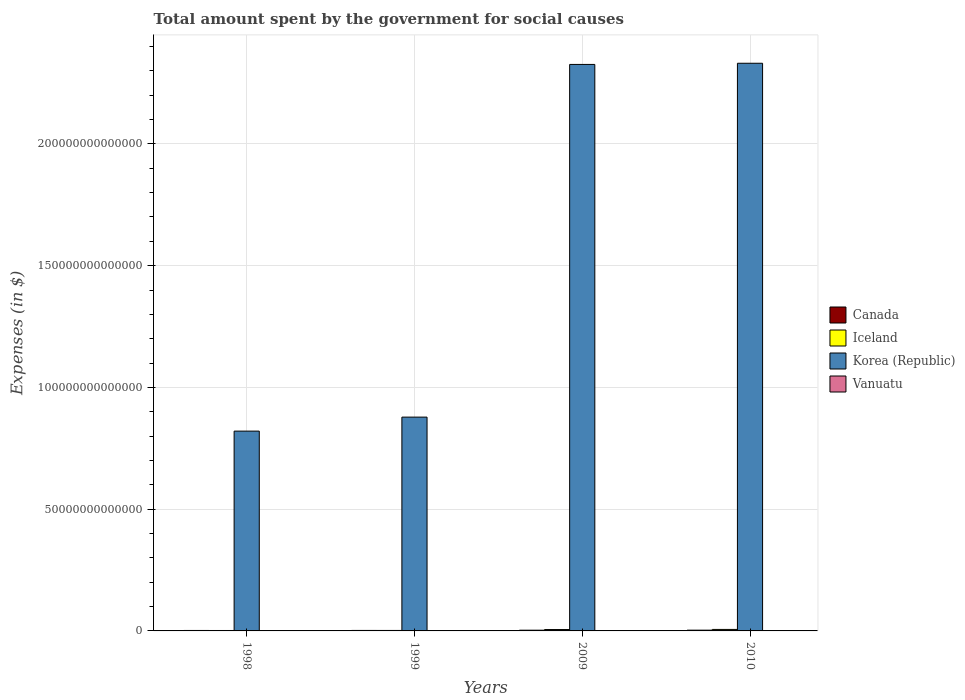How many different coloured bars are there?
Your response must be concise. 4. How many groups of bars are there?
Offer a very short reply. 4. Are the number of bars on each tick of the X-axis equal?
Offer a very short reply. Yes. What is the amount spent for social causes by the government in Vanuatu in 1998?
Give a very brief answer. 6.40e+09. Across all years, what is the maximum amount spent for social causes by the government in Canada?
Provide a succinct answer. 3.13e+11. Across all years, what is the minimum amount spent for social causes by the government in Canada?
Keep it short and to the point. 1.89e+11. What is the total amount spent for social causes by the government in Iceland in the graph?
Your response must be concise. 1.55e+12. What is the difference between the amount spent for social causes by the government in Canada in 1998 and that in 2009?
Offer a very short reply. -1.07e+11. What is the difference between the amount spent for social causes by the government in Korea (Republic) in 1998 and the amount spent for social causes by the government in Canada in 1999?
Ensure brevity in your answer.  8.19e+13. What is the average amount spent for social causes by the government in Iceland per year?
Make the answer very short. 3.88e+11. In the year 1998, what is the difference between the amount spent for social causes by the government in Canada and amount spent for social causes by the government in Vanuatu?
Provide a short and direct response. 1.83e+11. In how many years, is the amount spent for social causes by the government in Canada greater than 50000000000000 $?
Your answer should be very brief. 0. What is the ratio of the amount spent for social causes by the government in Vanuatu in 2009 to that in 2010?
Ensure brevity in your answer.  0.88. What is the difference between the highest and the second highest amount spent for social causes by the government in Korea (Republic)?
Your answer should be very brief. 4.79e+11. What is the difference between the highest and the lowest amount spent for social causes by the government in Canada?
Make the answer very short. 1.24e+11. In how many years, is the amount spent for social causes by the government in Korea (Republic) greater than the average amount spent for social causes by the government in Korea (Republic) taken over all years?
Your response must be concise. 2. Is it the case that in every year, the sum of the amount spent for social causes by the government in Vanuatu and amount spent for social causes by the government in Canada is greater than the sum of amount spent for social causes by the government in Iceland and amount spent for social causes by the government in Korea (Republic)?
Provide a succinct answer. Yes. What does the 1st bar from the left in 1999 represents?
Your answer should be very brief. Canada. What is the difference between two consecutive major ticks on the Y-axis?
Give a very brief answer. 5.00e+13. Are the values on the major ticks of Y-axis written in scientific E-notation?
Provide a succinct answer. No. Where does the legend appear in the graph?
Offer a very short reply. Center right. How are the legend labels stacked?
Your answer should be compact. Vertical. What is the title of the graph?
Give a very brief answer. Total amount spent by the government for social causes. What is the label or title of the Y-axis?
Ensure brevity in your answer.  Expenses (in $). What is the Expenses (in $) of Canada in 1998?
Your response must be concise. 1.89e+11. What is the Expenses (in $) of Iceland in 1998?
Your answer should be compact. 1.77e+11. What is the Expenses (in $) in Korea (Republic) in 1998?
Your response must be concise. 8.21e+13. What is the Expenses (in $) of Vanuatu in 1998?
Offer a very short reply. 6.40e+09. What is the Expenses (in $) in Canada in 1999?
Offer a terse response. 1.99e+11. What is the Expenses (in $) in Iceland in 1999?
Make the answer very short. 1.94e+11. What is the Expenses (in $) of Korea (Republic) in 1999?
Ensure brevity in your answer.  8.78e+13. What is the Expenses (in $) of Vanuatu in 1999?
Give a very brief answer. 6.51e+09. What is the Expenses (in $) in Canada in 2009?
Your response must be concise. 2.96e+11. What is the Expenses (in $) in Iceland in 2009?
Provide a short and direct response. 5.71e+11. What is the Expenses (in $) of Korea (Republic) in 2009?
Provide a succinct answer. 2.33e+14. What is the Expenses (in $) in Vanuatu in 2009?
Keep it short and to the point. 1.33e+1. What is the Expenses (in $) of Canada in 2010?
Your response must be concise. 3.13e+11. What is the Expenses (in $) in Iceland in 2010?
Your answer should be very brief. 6.10e+11. What is the Expenses (in $) of Korea (Republic) in 2010?
Make the answer very short. 2.33e+14. What is the Expenses (in $) of Vanuatu in 2010?
Your answer should be very brief. 1.51e+1. Across all years, what is the maximum Expenses (in $) in Canada?
Provide a succinct answer. 3.13e+11. Across all years, what is the maximum Expenses (in $) in Iceland?
Give a very brief answer. 6.10e+11. Across all years, what is the maximum Expenses (in $) in Korea (Republic)?
Your answer should be compact. 2.33e+14. Across all years, what is the maximum Expenses (in $) of Vanuatu?
Offer a very short reply. 1.51e+1. Across all years, what is the minimum Expenses (in $) in Canada?
Ensure brevity in your answer.  1.89e+11. Across all years, what is the minimum Expenses (in $) of Iceland?
Give a very brief answer. 1.77e+11. Across all years, what is the minimum Expenses (in $) in Korea (Republic)?
Your response must be concise. 8.21e+13. Across all years, what is the minimum Expenses (in $) of Vanuatu?
Your answer should be very brief. 6.40e+09. What is the total Expenses (in $) in Canada in the graph?
Your answer should be compact. 9.98e+11. What is the total Expenses (in $) in Iceland in the graph?
Your answer should be very brief. 1.55e+12. What is the total Expenses (in $) of Korea (Republic) in the graph?
Offer a terse response. 6.36e+14. What is the total Expenses (in $) of Vanuatu in the graph?
Offer a very short reply. 4.13e+1. What is the difference between the Expenses (in $) in Canada in 1998 and that in 1999?
Your answer should be very brief. -9.53e+09. What is the difference between the Expenses (in $) of Iceland in 1998 and that in 1999?
Your response must be concise. -1.73e+1. What is the difference between the Expenses (in $) of Korea (Republic) in 1998 and that in 1999?
Provide a succinct answer. -5.75e+12. What is the difference between the Expenses (in $) in Vanuatu in 1998 and that in 1999?
Provide a succinct answer. -1.08e+08. What is the difference between the Expenses (in $) of Canada in 1998 and that in 2009?
Offer a very short reply. -1.07e+11. What is the difference between the Expenses (in $) in Iceland in 1998 and that in 2009?
Give a very brief answer. -3.94e+11. What is the difference between the Expenses (in $) of Korea (Republic) in 1998 and that in 2009?
Provide a short and direct response. -1.51e+14. What is the difference between the Expenses (in $) of Vanuatu in 1998 and that in 2009?
Ensure brevity in your answer.  -6.87e+09. What is the difference between the Expenses (in $) of Canada in 1998 and that in 2010?
Your answer should be compact. -1.24e+11. What is the difference between the Expenses (in $) in Iceland in 1998 and that in 2010?
Give a very brief answer. -4.33e+11. What is the difference between the Expenses (in $) of Korea (Republic) in 1998 and that in 2010?
Your answer should be very brief. -1.51e+14. What is the difference between the Expenses (in $) in Vanuatu in 1998 and that in 2010?
Your answer should be compact. -8.71e+09. What is the difference between the Expenses (in $) of Canada in 1999 and that in 2009?
Offer a very short reply. -9.73e+1. What is the difference between the Expenses (in $) of Iceland in 1999 and that in 2009?
Your answer should be compact. -3.77e+11. What is the difference between the Expenses (in $) of Korea (Republic) in 1999 and that in 2009?
Provide a short and direct response. -1.45e+14. What is the difference between the Expenses (in $) of Vanuatu in 1999 and that in 2009?
Ensure brevity in your answer.  -6.76e+09. What is the difference between the Expenses (in $) of Canada in 1999 and that in 2010?
Offer a very short reply. -1.14e+11. What is the difference between the Expenses (in $) of Iceland in 1999 and that in 2010?
Provide a succinct answer. -4.16e+11. What is the difference between the Expenses (in $) of Korea (Republic) in 1999 and that in 2010?
Ensure brevity in your answer.  -1.45e+14. What is the difference between the Expenses (in $) of Vanuatu in 1999 and that in 2010?
Offer a very short reply. -8.60e+09. What is the difference between the Expenses (in $) of Canada in 2009 and that in 2010?
Give a very brief answer. -1.68e+1. What is the difference between the Expenses (in $) in Iceland in 2009 and that in 2010?
Your answer should be very brief. -3.92e+1. What is the difference between the Expenses (in $) in Korea (Republic) in 2009 and that in 2010?
Make the answer very short. -4.79e+11. What is the difference between the Expenses (in $) of Vanuatu in 2009 and that in 2010?
Provide a short and direct response. -1.84e+09. What is the difference between the Expenses (in $) of Canada in 1998 and the Expenses (in $) of Iceland in 1999?
Provide a short and direct response. -4.72e+09. What is the difference between the Expenses (in $) of Canada in 1998 and the Expenses (in $) of Korea (Republic) in 1999?
Your answer should be very brief. -8.76e+13. What is the difference between the Expenses (in $) of Canada in 1998 and the Expenses (in $) of Vanuatu in 1999?
Your answer should be very brief. 1.83e+11. What is the difference between the Expenses (in $) in Iceland in 1998 and the Expenses (in $) in Korea (Republic) in 1999?
Make the answer very short. -8.76e+13. What is the difference between the Expenses (in $) of Iceland in 1998 and the Expenses (in $) of Vanuatu in 1999?
Ensure brevity in your answer.  1.70e+11. What is the difference between the Expenses (in $) of Korea (Republic) in 1998 and the Expenses (in $) of Vanuatu in 1999?
Your answer should be compact. 8.21e+13. What is the difference between the Expenses (in $) in Canada in 1998 and the Expenses (in $) in Iceland in 2009?
Offer a terse response. -3.81e+11. What is the difference between the Expenses (in $) in Canada in 1998 and the Expenses (in $) in Korea (Republic) in 2009?
Make the answer very short. -2.32e+14. What is the difference between the Expenses (in $) of Canada in 1998 and the Expenses (in $) of Vanuatu in 2009?
Provide a succinct answer. 1.76e+11. What is the difference between the Expenses (in $) in Iceland in 1998 and the Expenses (in $) in Korea (Republic) in 2009?
Your answer should be very brief. -2.32e+14. What is the difference between the Expenses (in $) of Iceland in 1998 and the Expenses (in $) of Vanuatu in 2009?
Your answer should be compact. 1.64e+11. What is the difference between the Expenses (in $) of Korea (Republic) in 1998 and the Expenses (in $) of Vanuatu in 2009?
Ensure brevity in your answer.  8.20e+13. What is the difference between the Expenses (in $) in Canada in 1998 and the Expenses (in $) in Iceland in 2010?
Offer a very short reply. -4.20e+11. What is the difference between the Expenses (in $) of Canada in 1998 and the Expenses (in $) of Korea (Republic) in 2010?
Keep it short and to the point. -2.33e+14. What is the difference between the Expenses (in $) in Canada in 1998 and the Expenses (in $) in Vanuatu in 2010?
Your answer should be compact. 1.74e+11. What is the difference between the Expenses (in $) of Iceland in 1998 and the Expenses (in $) of Korea (Republic) in 2010?
Give a very brief answer. -2.33e+14. What is the difference between the Expenses (in $) in Iceland in 1998 and the Expenses (in $) in Vanuatu in 2010?
Offer a very short reply. 1.62e+11. What is the difference between the Expenses (in $) of Korea (Republic) in 1998 and the Expenses (in $) of Vanuatu in 2010?
Offer a very short reply. 8.20e+13. What is the difference between the Expenses (in $) in Canada in 1999 and the Expenses (in $) in Iceland in 2009?
Provide a short and direct response. -3.72e+11. What is the difference between the Expenses (in $) of Canada in 1999 and the Expenses (in $) of Korea (Republic) in 2009?
Provide a short and direct response. -2.32e+14. What is the difference between the Expenses (in $) in Canada in 1999 and the Expenses (in $) in Vanuatu in 2009?
Your response must be concise. 1.86e+11. What is the difference between the Expenses (in $) in Iceland in 1999 and the Expenses (in $) in Korea (Republic) in 2009?
Give a very brief answer. -2.32e+14. What is the difference between the Expenses (in $) of Iceland in 1999 and the Expenses (in $) of Vanuatu in 2009?
Give a very brief answer. 1.81e+11. What is the difference between the Expenses (in $) in Korea (Republic) in 1999 and the Expenses (in $) in Vanuatu in 2009?
Offer a very short reply. 8.78e+13. What is the difference between the Expenses (in $) of Canada in 1999 and the Expenses (in $) of Iceland in 2010?
Give a very brief answer. -4.11e+11. What is the difference between the Expenses (in $) of Canada in 1999 and the Expenses (in $) of Korea (Republic) in 2010?
Give a very brief answer. -2.33e+14. What is the difference between the Expenses (in $) of Canada in 1999 and the Expenses (in $) of Vanuatu in 2010?
Provide a succinct answer. 1.84e+11. What is the difference between the Expenses (in $) of Iceland in 1999 and the Expenses (in $) of Korea (Republic) in 2010?
Give a very brief answer. -2.33e+14. What is the difference between the Expenses (in $) of Iceland in 1999 and the Expenses (in $) of Vanuatu in 2010?
Give a very brief answer. 1.79e+11. What is the difference between the Expenses (in $) in Korea (Republic) in 1999 and the Expenses (in $) in Vanuatu in 2010?
Give a very brief answer. 8.78e+13. What is the difference between the Expenses (in $) of Canada in 2009 and the Expenses (in $) of Iceland in 2010?
Your response must be concise. -3.14e+11. What is the difference between the Expenses (in $) of Canada in 2009 and the Expenses (in $) of Korea (Republic) in 2010?
Your answer should be very brief. -2.33e+14. What is the difference between the Expenses (in $) in Canada in 2009 and the Expenses (in $) in Vanuatu in 2010?
Make the answer very short. 2.81e+11. What is the difference between the Expenses (in $) in Iceland in 2009 and the Expenses (in $) in Korea (Republic) in 2010?
Make the answer very short. -2.33e+14. What is the difference between the Expenses (in $) in Iceland in 2009 and the Expenses (in $) in Vanuatu in 2010?
Ensure brevity in your answer.  5.56e+11. What is the difference between the Expenses (in $) of Korea (Republic) in 2009 and the Expenses (in $) of Vanuatu in 2010?
Keep it short and to the point. 2.33e+14. What is the average Expenses (in $) in Canada per year?
Your response must be concise. 2.49e+11. What is the average Expenses (in $) of Iceland per year?
Offer a terse response. 3.88e+11. What is the average Expenses (in $) in Korea (Republic) per year?
Your answer should be very brief. 1.59e+14. What is the average Expenses (in $) in Vanuatu per year?
Keep it short and to the point. 1.03e+1. In the year 1998, what is the difference between the Expenses (in $) of Canada and Expenses (in $) of Iceland?
Your response must be concise. 1.26e+1. In the year 1998, what is the difference between the Expenses (in $) in Canada and Expenses (in $) in Korea (Republic)?
Give a very brief answer. -8.19e+13. In the year 1998, what is the difference between the Expenses (in $) in Canada and Expenses (in $) in Vanuatu?
Your answer should be very brief. 1.83e+11. In the year 1998, what is the difference between the Expenses (in $) of Iceland and Expenses (in $) of Korea (Republic)?
Offer a very short reply. -8.19e+13. In the year 1998, what is the difference between the Expenses (in $) of Iceland and Expenses (in $) of Vanuatu?
Give a very brief answer. 1.70e+11. In the year 1998, what is the difference between the Expenses (in $) of Korea (Republic) and Expenses (in $) of Vanuatu?
Provide a succinct answer. 8.21e+13. In the year 1999, what is the difference between the Expenses (in $) in Canada and Expenses (in $) in Iceland?
Provide a short and direct response. 4.81e+09. In the year 1999, what is the difference between the Expenses (in $) of Canada and Expenses (in $) of Korea (Republic)?
Ensure brevity in your answer.  -8.76e+13. In the year 1999, what is the difference between the Expenses (in $) of Canada and Expenses (in $) of Vanuatu?
Keep it short and to the point. 1.92e+11. In the year 1999, what is the difference between the Expenses (in $) in Iceland and Expenses (in $) in Korea (Republic)?
Ensure brevity in your answer.  -8.76e+13. In the year 1999, what is the difference between the Expenses (in $) in Iceland and Expenses (in $) in Vanuatu?
Provide a succinct answer. 1.88e+11. In the year 1999, what is the difference between the Expenses (in $) of Korea (Republic) and Expenses (in $) of Vanuatu?
Your answer should be very brief. 8.78e+13. In the year 2009, what is the difference between the Expenses (in $) in Canada and Expenses (in $) in Iceland?
Your response must be concise. -2.74e+11. In the year 2009, what is the difference between the Expenses (in $) of Canada and Expenses (in $) of Korea (Republic)?
Your answer should be very brief. -2.32e+14. In the year 2009, what is the difference between the Expenses (in $) in Canada and Expenses (in $) in Vanuatu?
Your answer should be very brief. 2.83e+11. In the year 2009, what is the difference between the Expenses (in $) in Iceland and Expenses (in $) in Korea (Republic)?
Offer a very short reply. -2.32e+14. In the year 2009, what is the difference between the Expenses (in $) of Iceland and Expenses (in $) of Vanuatu?
Your response must be concise. 5.57e+11. In the year 2009, what is the difference between the Expenses (in $) of Korea (Republic) and Expenses (in $) of Vanuatu?
Offer a very short reply. 2.33e+14. In the year 2010, what is the difference between the Expenses (in $) of Canada and Expenses (in $) of Iceland?
Keep it short and to the point. -2.97e+11. In the year 2010, what is the difference between the Expenses (in $) in Canada and Expenses (in $) in Korea (Republic)?
Keep it short and to the point. -2.33e+14. In the year 2010, what is the difference between the Expenses (in $) of Canada and Expenses (in $) of Vanuatu?
Make the answer very short. 2.98e+11. In the year 2010, what is the difference between the Expenses (in $) in Iceland and Expenses (in $) in Korea (Republic)?
Provide a short and direct response. -2.33e+14. In the year 2010, what is the difference between the Expenses (in $) in Iceland and Expenses (in $) in Vanuatu?
Your response must be concise. 5.95e+11. In the year 2010, what is the difference between the Expenses (in $) in Korea (Republic) and Expenses (in $) in Vanuatu?
Provide a succinct answer. 2.33e+14. What is the ratio of the Expenses (in $) of Canada in 1998 to that in 1999?
Offer a terse response. 0.95. What is the ratio of the Expenses (in $) in Iceland in 1998 to that in 1999?
Your response must be concise. 0.91. What is the ratio of the Expenses (in $) of Korea (Republic) in 1998 to that in 1999?
Your response must be concise. 0.93. What is the ratio of the Expenses (in $) of Vanuatu in 1998 to that in 1999?
Your answer should be very brief. 0.98. What is the ratio of the Expenses (in $) of Canada in 1998 to that in 2009?
Your response must be concise. 0.64. What is the ratio of the Expenses (in $) of Iceland in 1998 to that in 2009?
Provide a succinct answer. 0.31. What is the ratio of the Expenses (in $) of Korea (Republic) in 1998 to that in 2009?
Your response must be concise. 0.35. What is the ratio of the Expenses (in $) in Vanuatu in 1998 to that in 2009?
Your response must be concise. 0.48. What is the ratio of the Expenses (in $) of Canada in 1998 to that in 2010?
Make the answer very short. 0.61. What is the ratio of the Expenses (in $) of Iceland in 1998 to that in 2010?
Your answer should be very brief. 0.29. What is the ratio of the Expenses (in $) in Korea (Republic) in 1998 to that in 2010?
Offer a very short reply. 0.35. What is the ratio of the Expenses (in $) of Vanuatu in 1998 to that in 2010?
Provide a succinct answer. 0.42. What is the ratio of the Expenses (in $) of Canada in 1999 to that in 2009?
Give a very brief answer. 0.67. What is the ratio of the Expenses (in $) in Iceland in 1999 to that in 2009?
Your answer should be very brief. 0.34. What is the ratio of the Expenses (in $) in Korea (Republic) in 1999 to that in 2009?
Provide a succinct answer. 0.38. What is the ratio of the Expenses (in $) in Vanuatu in 1999 to that in 2009?
Your answer should be very brief. 0.49. What is the ratio of the Expenses (in $) of Canada in 1999 to that in 2010?
Offer a very short reply. 0.64. What is the ratio of the Expenses (in $) of Iceland in 1999 to that in 2010?
Your response must be concise. 0.32. What is the ratio of the Expenses (in $) of Korea (Republic) in 1999 to that in 2010?
Keep it short and to the point. 0.38. What is the ratio of the Expenses (in $) of Vanuatu in 1999 to that in 2010?
Give a very brief answer. 0.43. What is the ratio of the Expenses (in $) of Canada in 2009 to that in 2010?
Your answer should be compact. 0.95. What is the ratio of the Expenses (in $) in Iceland in 2009 to that in 2010?
Provide a succinct answer. 0.94. What is the ratio of the Expenses (in $) of Vanuatu in 2009 to that in 2010?
Offer a terse response. 0.88. What is the difference between the highest and the second highest Expenses (in $) of Canada?
Your answer should be compact. 1.68e+1. What is the difference between the highest and the second highest Expenses (in $) in Iceland?
Your answer should be compact. 3.92e+1. What is the difference between the highest and the second highest Expenses (in $) in Korea (Republic)?
Offer a terse response. 4.79e+11. What is the difference between the highest and the second highest Expenses (in $) of Vanuatu?
Provide a succinct answer. 1.84e+09. What is the difference between the highest and the lowest Expenses (in $) of Canada?
Your answer should be very brief. 1.24e+11. What is the difference between the highest and the lowest Expenses (in $) in Iceland?
Your answer should be compact. 4.33e+11. What is the difference between the highest and the lowest Expenses (in $) of Korea (Republic)?
Your answer should be compact. 1.51e+14. What is the difference between the highest and the lowest Expenses (in $) in Vanuatu?
Keep it short and to the point. 8.71e+09. 